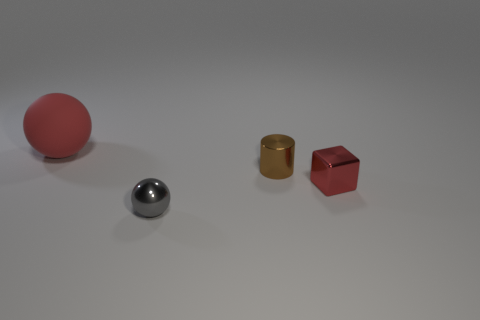There is a block that is the same color as the rubber thing; what is its size?
Make the answer very short. Small. There is a matte object; is it the same color as the tiny object that is right of the tiny metal cylinder?
Your answer should be compact. Yes. There is a red ball to the left of the ball to the right of the red thing behind the metallic cube; what is it made of?
Make the answer very short. Rubber. There is a shiny object that is to the right of the small cylinder; what shape is it?
Your answer should be very brief. Cube. What number of other tiny gray objects have the same shape as the gray object?
Ensure brevity in your answer.  0. There is a thing that is behind the brown cylinder; is its color the same as the shiny block?
Make the answer very short. Yes. How many rubber balls are in front of the ball that is on the right side of the red thing left of the gray metallic thing?
Offer a very short reply. 0. How many red things are both in front of the rubber thing and to the left of the brown cylinder?
Give a very brief answer. 0. What is the shape of the small shiny thing that is the same color as the rubber thing?
Make the answer very short. Cube. Is there any other thing that is made of the same material as the large red ball?
Keep it short and to the point. No. 